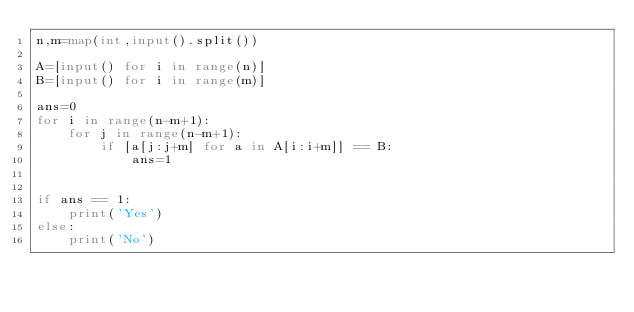Convert code to text. <code><loc_0><loc_0><loc_500><loc_500><_Python_>n,m=map(int,input().split())

A=[input() for i in range(n)]
B=[input() for i in range(m)]

ans=0        
for i in range(n-m+1):
    for j in range(n-m+1):
        if [a[j:j+m] for a in A[i:i+m]] == B:
            ans=1
        
        
if ans == 1:
    print('Yes')
else:
    print('No')
</code> 